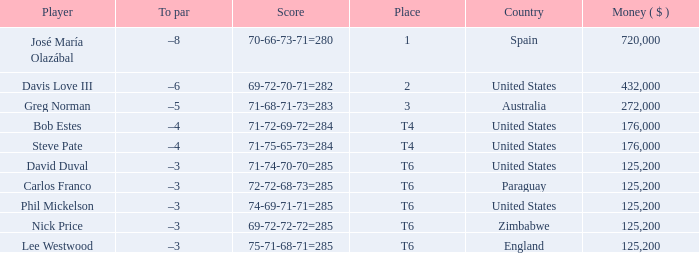Which Score has a Place of 3? 71-68-71-73=283. 